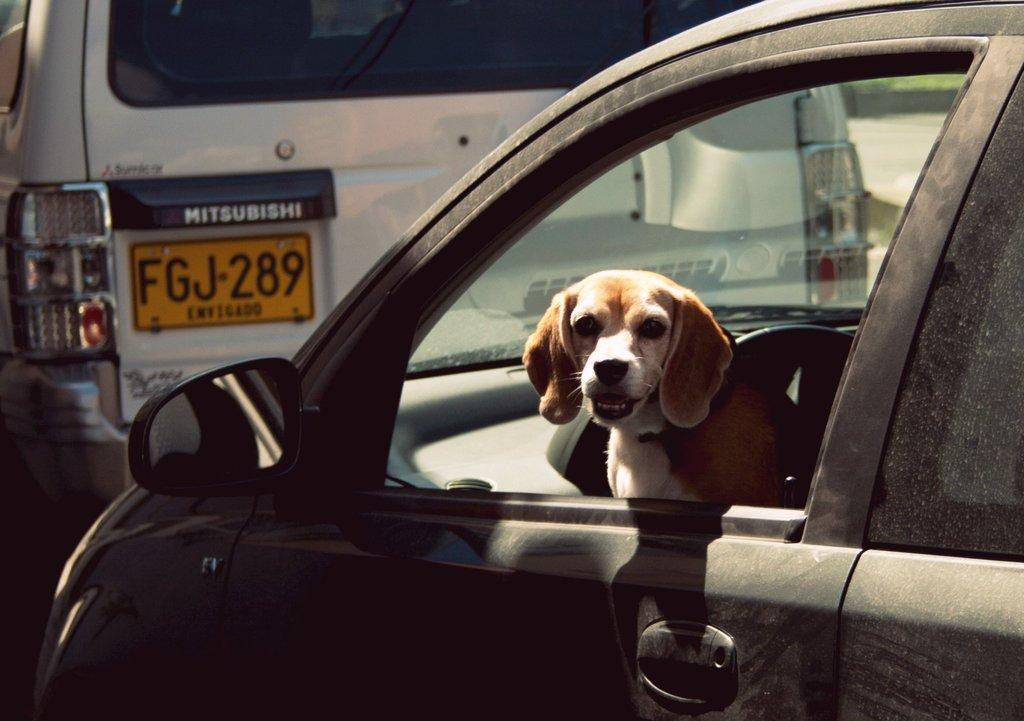How many cars are present in the image? There are two cars in the image. Can you describe the presence of any animals in the image? Yes, there is a dog inside one of the cars. What additional feature can be seen on the cars in the image? The image contains a car's mirror. How many eyes does the dog have in the image? The image does not show the dog's eyes, so it is not possible to determine the number of eyes the dog has. 